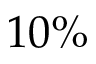Convert formula to latex. <formula><loc_0><loc_0><loc_500><loc_500>1 0 \%</formula> 